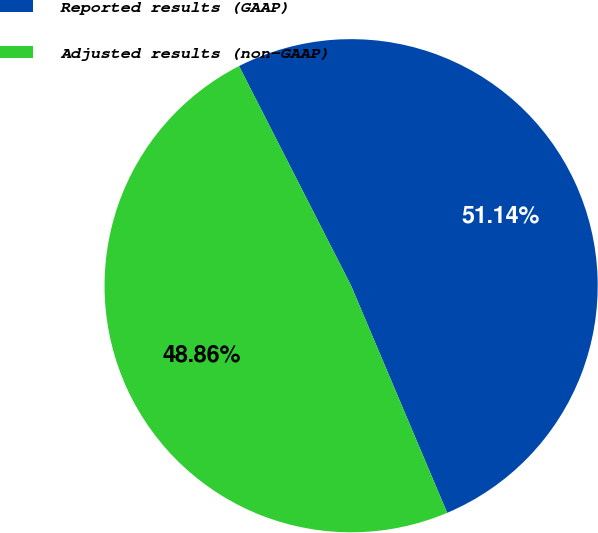Convert chart. <chart><loc_0><loc_0><loc_500><loc_500><pie_chart><fcel>Reported results (GAAP)<fcel>Adjusted results (non-GAAP)<nl><fcel>51.14%<fcel>48.86%<nl></chart> 